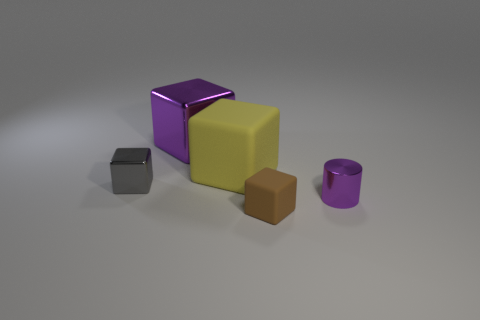Subtract 1 blocks. How many blocks are left? 3 Subtract all red cylinders. Subtract all brown cubes. How many cylinders are left? 1 Add 2 yellow cylinders. How many objects exist? 7 Subtract all cubes. How many objects are left? 1 Add 1 small rubber things. How many small rubber things exist? 2 Subtract 0 cyan blocks. How many objects are left? 5 Subtract all small gray matte objects. Subtract all small purple shiny objects. How many objects are left? 4 Add 4 brown cubes. How many brown cubes are left? 5 